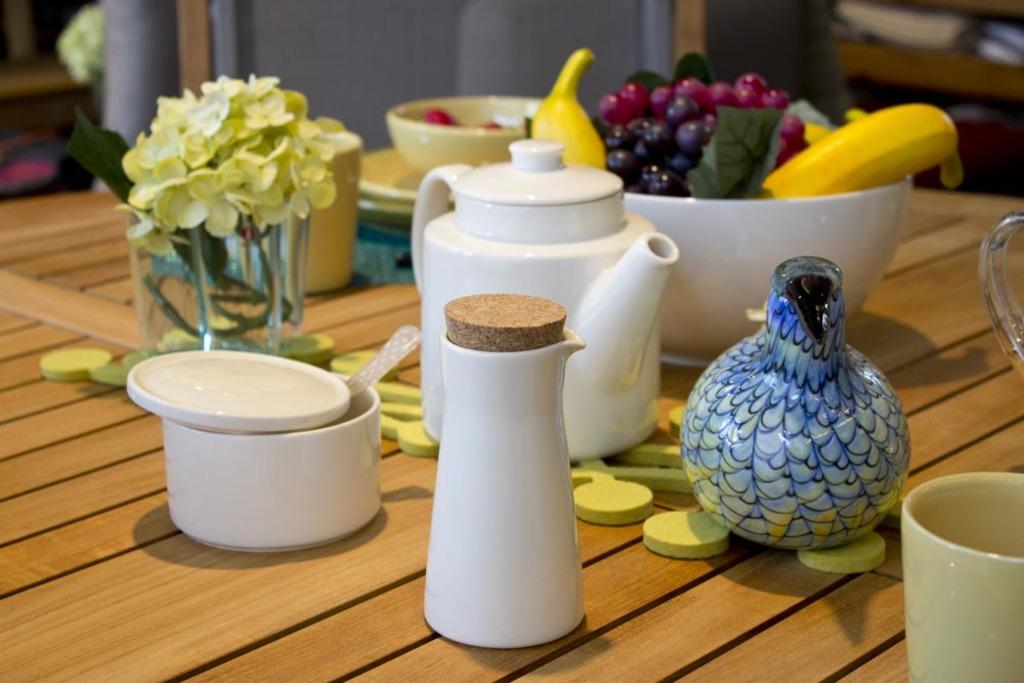What type of container is present in the image? There is a cup, a jar, and a tea pot in the image. What else can be seen on the table in the image? There is a bowl full of fruits and a flower vase in the image. What might be used for serving hot beverages in the image? The tea pot in the image can be used for serving hot beverages. What type of food is visible in the bowl in the image? The bowl is full of fruits in the image. How much money is on the table in the image? There is no money visible in the image; it only contains a cup, a jar, a tea pot, a bowl of fruits, and a flower vase. 